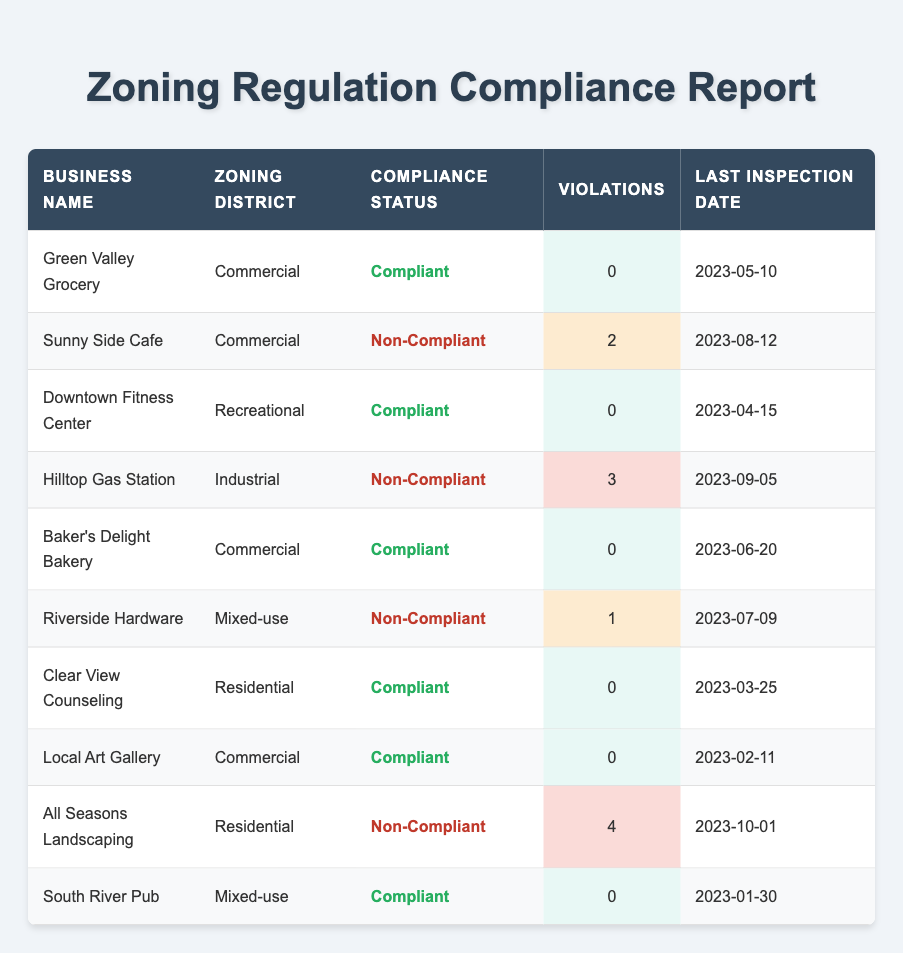What is the compliance status of Green Valley Grocery? Referring to the table, the compliance status for Green Valley Grocery is listed directly under the compliance status column.
Answer: Compliant How many violations does Sunny Side Cafe have? Looking at the violations column in the table, Sunny Side Cafe shows that it has 2 violations.
Answer: 2 Is Riverside Hardware compliant with zoning regulations? By checking the compliance status of Riverside Hardware in the table, it shows "Non-Compliant."
Answer: No How many businesses in the Commercial zoning district are compliant? In the table, the businesses in the Commercial zoning district are Green Valley Grocery, Sunny Side Cafe, Baker's Delight Bakery, and Local Art Gallery. Out of these, Green Valley Grocery, Baker's Delight Bakery, and Local Art Gallery are compliant, totaling 3 compliant businesses.
Answer: 3 What is the average number of violations for compliant businesses? First, we identify the compliant businesses: Green Valley Grocery, Downtown Fitness Center, Baker's Delight Bakery, Clear View Counseling, Local Art Gallery, and South River Pub, all with 0 violations. The sum of their violations is 0, and since there are 6 compliant businesses, the average is 0/6 = 0.
Answer: 0 Which business has the most violations and how many are they? By reviewing the violations column for all businesses, All Seasons Landscaping has the highest number of violations at 4.
Answer: All Seasons Landscaping, 4 Is Clear View Counseling compliant? The compliance status listed next to Clear View Counseling in the table is "Compliant."
Answer: Yes How many total violations are recorded among non-compliant businesses? To find the total, we sum the violations of non-compliant businesses: Sunny Side Cafe (2) + Hilltop Gas Station (3) + Riverside Hardware (1) + All Seasons Landscaping (4) = 10 total violations.
Answer: 10 What was the last inspection date for Hilltop Gas Station? The last inspection date listed for Hilltop Gas Station in the table is 2023-09-05.
Answer: 2023-09-05 